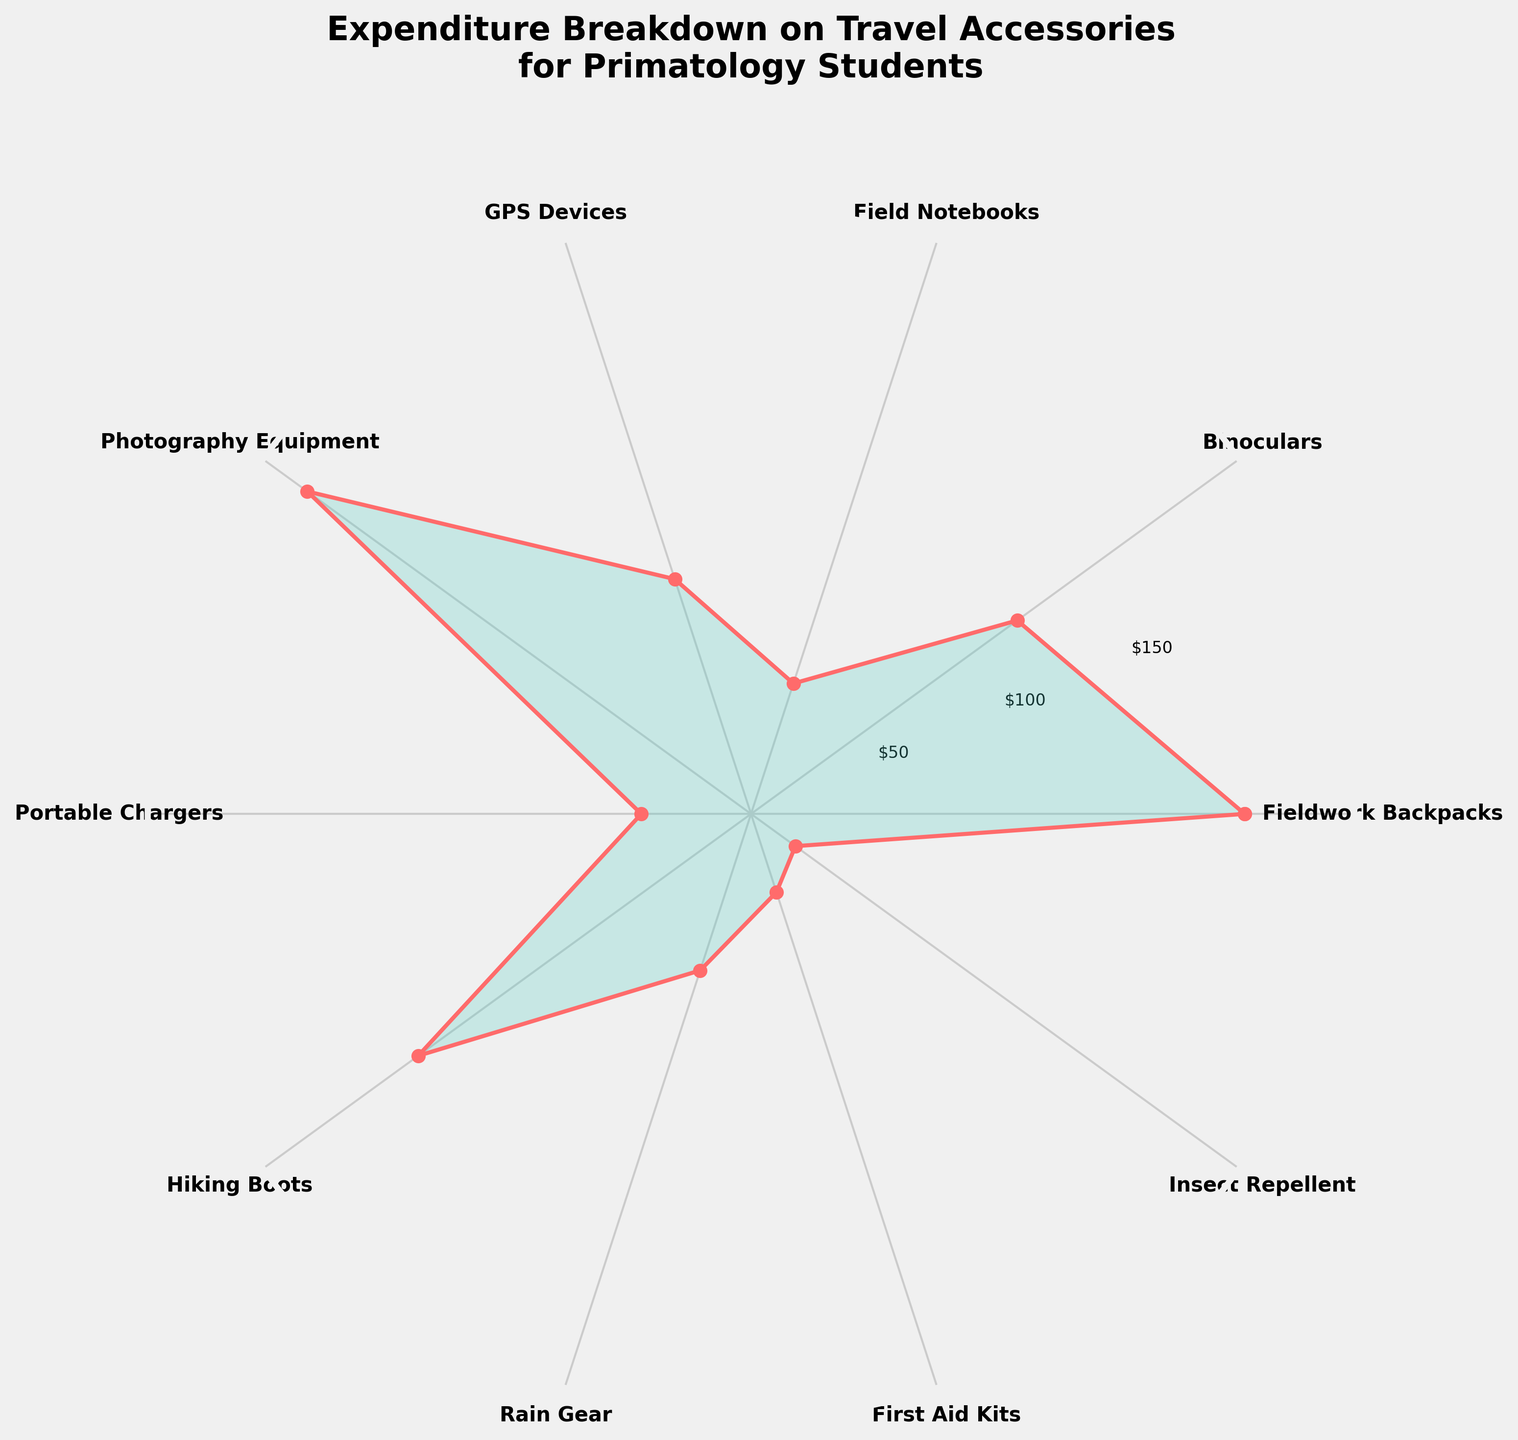What is the title of the rose chart? The title is typically displayed at the top of the figure. In this chart, it reads "Expenditure Breakdown on Travel Accessories for Primatology Students"
Answer: Expenditure Breakdown on Travel Accessories for Primatology Students How much is spent on Fieldwork Backpacks? The amount spent on Fieldwork Backpacks is represented by the length reaching the category label and the radial ticks. We can find that 180 dollars is marked.
Answer: 180 Which travel accessory has the highest expenditure? By examining the lengths of each section towards the outer edge of the plot, we can identify that Photography Equipment has the highest expenditure.
Answer: Photography Equipment Which two categories have the lowest expenditures, and what are their amounts? The categories with the shortest lengths to the outer edge are First Aid Kits and Insect Repellent. Their amounts are 30 and 20 dollars, respectively.
Answer: First Aid Kits: 30, Insect Repellent: 20 What is the total expenditure on GPS Devices, Field Notebooks, and Hiking Boots combined? Summing the amounts spent on these three categories: 90 (GPS Devices) + 50 (Field Notebooks) + 150 (Hiking Boots) equals 290 dollars.
Answer: 290 How many categories have expenditures greater than or equal to 100 dollars? Categories with expenditures greater than or equal to 100 dollars are Fieldwork Backpacks, Binoculars, Photography Equipment, and Hiking Boots. We can count these as four categories.
Answer: 4 Which category has the smallest expenditure, and how much is it? By identifying the shortest length reaching the category label, we find that Insect Repellent has the smallest expenditure, which is 20 dollars.
Answer: Insect Repellent: 20 What is the average expenditure across all categories? To find the average, sum all expenditures and divide by the number of categories: (180 + 120 + 50 + 90 + 200 + 40 + 150 + 60 + 30 + 20) / 10 = 940 / 10 = 94 dollars.
Answer: 94 Order the expenditures from highest to lowest. What are the first three categories listed? Sorting the amounts from highest to lowest, we get: Photography Equipment, Fieldwork Backpacks, Hiking Boots. These correspond to the largest three categories.
Answer: Photography Equipment, Fieldwork Backpacks, Hiking Boots How much more is spent on Photography Equipment compared to Portable Chargers? Subtract the expenditure for Portable Chargers from the expenditure for Photography Equipment: 200 - 40 = 160 dollars.
Answer: 160 